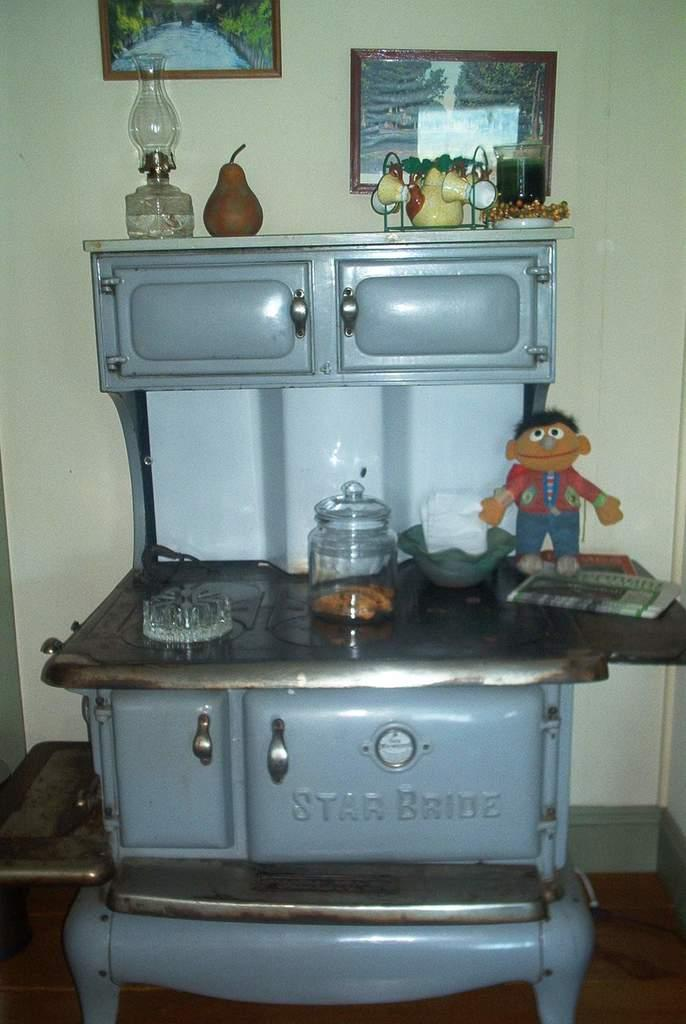<image>
Render a clear and concise summary of the photo. An antique Star Bride oven with items sitting on top of it. 